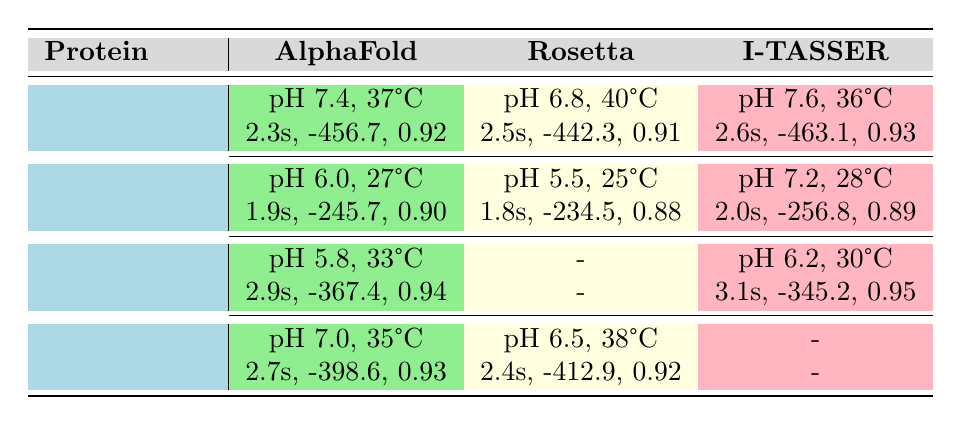What is the folding time for Hemoglobin when simulated using AlphaFold? The table lists Hemoglobin's folding time under the AlphaFold algorithm as 2.3 seconds.
Answer: 2.3 seconds Which protein has the highest structural accuracy and what is that value? By examining the structural accuracy values for each protein, Lysozyme has the highest structural accuracy of 0.95.
Answer: 0.95 What is the energy score for Myoglobin using the Rosetta algorithm? In the table, Myoglobin's energy score using the Rosetta algorithm is listed as -412.9.
Answer: -412.9 Is the folding time for Insulin using Rosetta shorter than the time for Myoglobin using AlphaFold? Insulin's folding time with Rosetta is 1.8 seconds, and Myoglobin's time with AlphaFold is 2.7 seconds. Since 1.8 is less than 2.7, the statement is true.
Answer: Yes What is the average folding time for the proteins summarized in the table? To find the average folding time, sum the folding times of all proteins (2.3 + 1.8 + 3.1 + 2.7 + 2.5 + 2.0 + 2.9 + 2.4 + 2.6 + 1.9 = 24.1) and divide by the number of proteins (10). Thus, the average folding time is 24.1 / 10 = 2.41 seconds.
Answer: 2.41 seconds What is the environmental condition for the Insulin simulation conducted with the AlphaFold algorithm? The AlphaFold simulation for Insulin shows the condition as pH 6.0 and temperature 27 degrees Celsius.
Answer: pH 6.0, 27°C Did any of the proteins use I-TASSER in both environmental conditions mentioned? By reviewing the table, Lysozyme and Hemoglobin show datasets using I-TASSER, but none of the conditions are repeated for the same protein, confirming no proteins used I-TASSER in both conditions.
Answer: No Which algorithm simulated Insulin with the lowest folding time and what was that time? Insulin's lowest folding time is listed under the Rosetta algorithm with a value of 1.8 seconds, which is lower than both other algorithms (AlphaFold and I-TASSER).
Answer: 1.8 seconds 